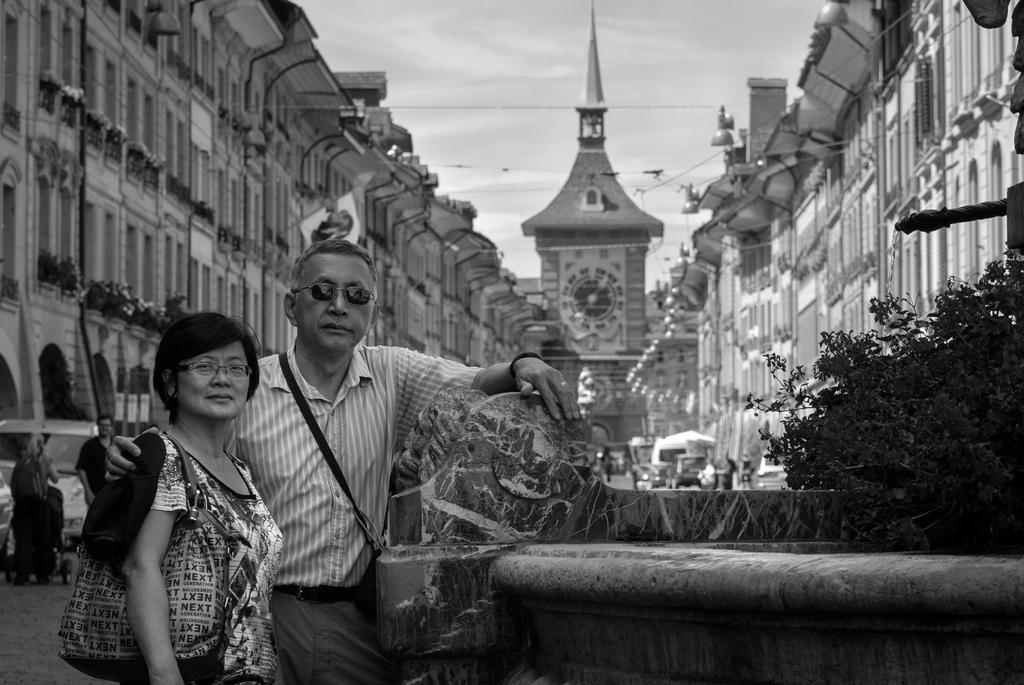Could you give a brief overview of what you see in this image? It looks like a black and white picture. We can see there are two people standing on the path and on the right side of the people there are plants. Behind the people there are some vehicles on the road, buildings and cables. Behind the buildings there is a sky. 